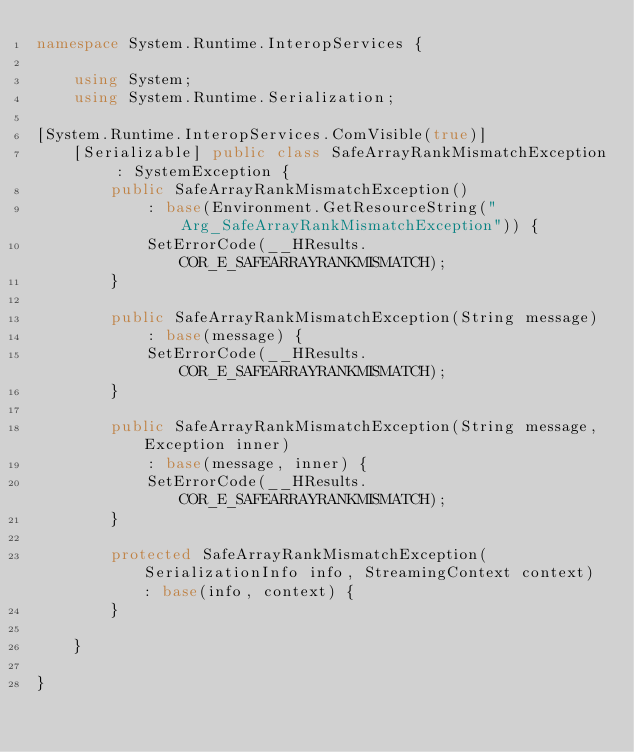Convert code to text. <code><loc_0><loc_0><loc_500><loc_500><_C#_>namespace System.Runtime.InteropServices {

    using System;
    using System.Runtime.Serialization;

[System.Runtime.InteropServices.ComVisible(true)]
    [Serializable] public class SafeArrayRankMismatchException : SystemException {
        public SafeArrayRankMismatchException() 
            : base(Environment.GetResourceString("Arg_SafeArrayRankMismatchException")) {
            SetErrorCode(__HResults.COR_E_SAFEARRAYRANKMISMATCH);
        }
    
        public SafeArrayRankMismatchException(String message) 
            : base(message) {
            SetErrorCode(__HResults.COR_E_SAFEARRAYRANKMISMATCH);
        }
    
        public SafeArrayRankMismatchException(String message, Exception inner) 
            : base(message, inner) {
            SetErrorCode(__HResults.COR_E_SAFEARRAYRANKMISMATCH);
        }

        protected SafeArrayRankMismatchException(SerializationInfo info, StreamingContext context) : base(info, context) {
        }

    }

}
</code> 